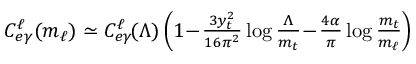<formula> <loc_0><loc_0><loc_500><loc_500>\begin{array} { r } { \, C _ { e \gamma } ^ { \ell } ( m _ { \ell } ) \simeq C _ { e \gamma } ^ { \ell } \, ( \Lambda ) \left ( 1 \, - \, \frac { 3 y _ { t } ^ { 2 } } { 1 6 \pi ^ { 2 } } \log \frac { \Lambda } { m _ { t } } \, - \, \frac { 4 \alpha } { \pi } \log \frac { m _ { t } } { m _ { \ell } } \right ) } \end{array}</formula> 